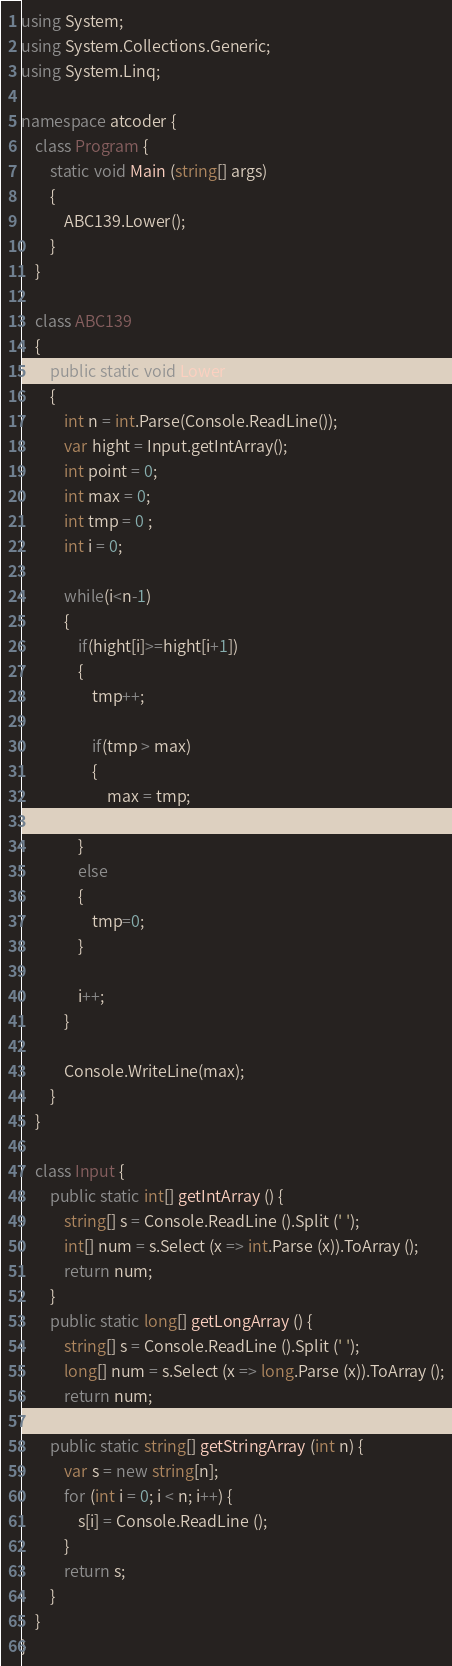Convert code to text. <code><loc_0><loc_0><loc_500><loc_500><_C#_>using System;
using System.Collections.Generic;
using System.Linq;

namespace atcoder {
    class Program {
        static void Main (string[] args)
        {
            ABC139.Lower();
        }
    }

    class ABC139
    {
        public static void Lower()
        {
            int n = int.Parse(Console.ReadLine());
            var hight = Input.getIntArray();
            int point = 0;
            int max = 0;
            int tmp = 0 ;
            int i = 0;

            while(i<n-1)
            {
                if(hight[i]>=hight[i+1])
                {
                    tmp++;    
                    
                    if(tmp > max)
                    {
                        max = tmp;
                    }
                }
                else
                {
                    tmp=0;
                }
                
                i++;
            }

            Console.WriteLine(max);
        }    
    }

    class Input {
        public static int[] getIntArray () {
            string[] s = Console.ReadLine ().Split (' ');
            int[] num = s.Select (x => int.Parse (x)).ToArray ();
            return num;
        }
        public static long[] getLongArray () {
            string[] s = Console.ReadLine ().Split (' ');
            long[] num = s.Select (x => long.Parse (x)).ToArray ();
            return num;
        }
        public static string[] getStringArray (int n) {
            var s = new string[n];
            for (int i = 0; i < n; i++) {
                s[i] = Console.ReadLine ();
            }
            return s;
        }
    }
}</code> 